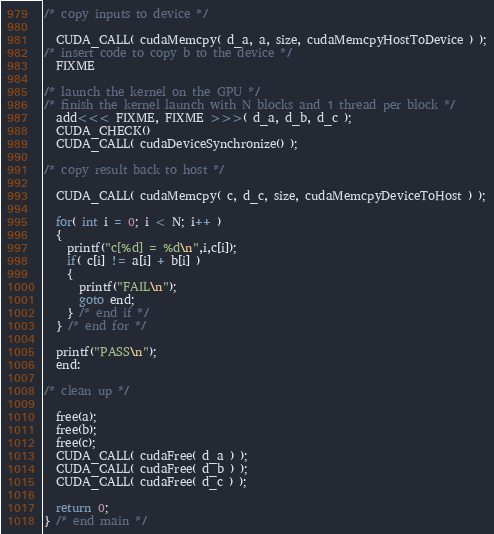Convert code to text. <code><loc_0><loc_0><loc_500><loc_500><_Cuda_>/* copy inputs to device */

  CUDA_CALL( cudaMemcpy( d_a, a, size, cudaMemcpyHostToDevice ) );
/* insert code to copy b to the device */
  FIXME

/* launch the kernel on the GPU */
/* finish the kernel launch with N blocks and 1 thread per block */
  add<<< FIXME, FIXME >>>( d_a, d_b, d_c );
  CUDA_CHECK()
  CUDA_CALL( cudaDeviceSynchronize() );

/* copy result back to host */

  CUDA_CALL( cudaMemcpy( c, d_c, size, cudaMemcpyDeviceToHost ) );

  for( int i = 0; i < N; i++ )
  {
    printf("c[%d] = %d\n",i,c[i]);
    if( c[i] != a[i] + b[i] )
    {
      printf("FAIL\n");
      goto end;
    } /* end if */
  } /* end for */

  printf("PASS\n");
  end:

/* clean up */

  free(a);
  free(b);
  free(c);
  CUDA_CALL( cudaFree( d_a ) );
  CUDA_CALL( cudaFree( d_b ) );
  CUDA_CALL( cudaFree( d_c ) );
	
  return 0;
} /* end main */
</code> 